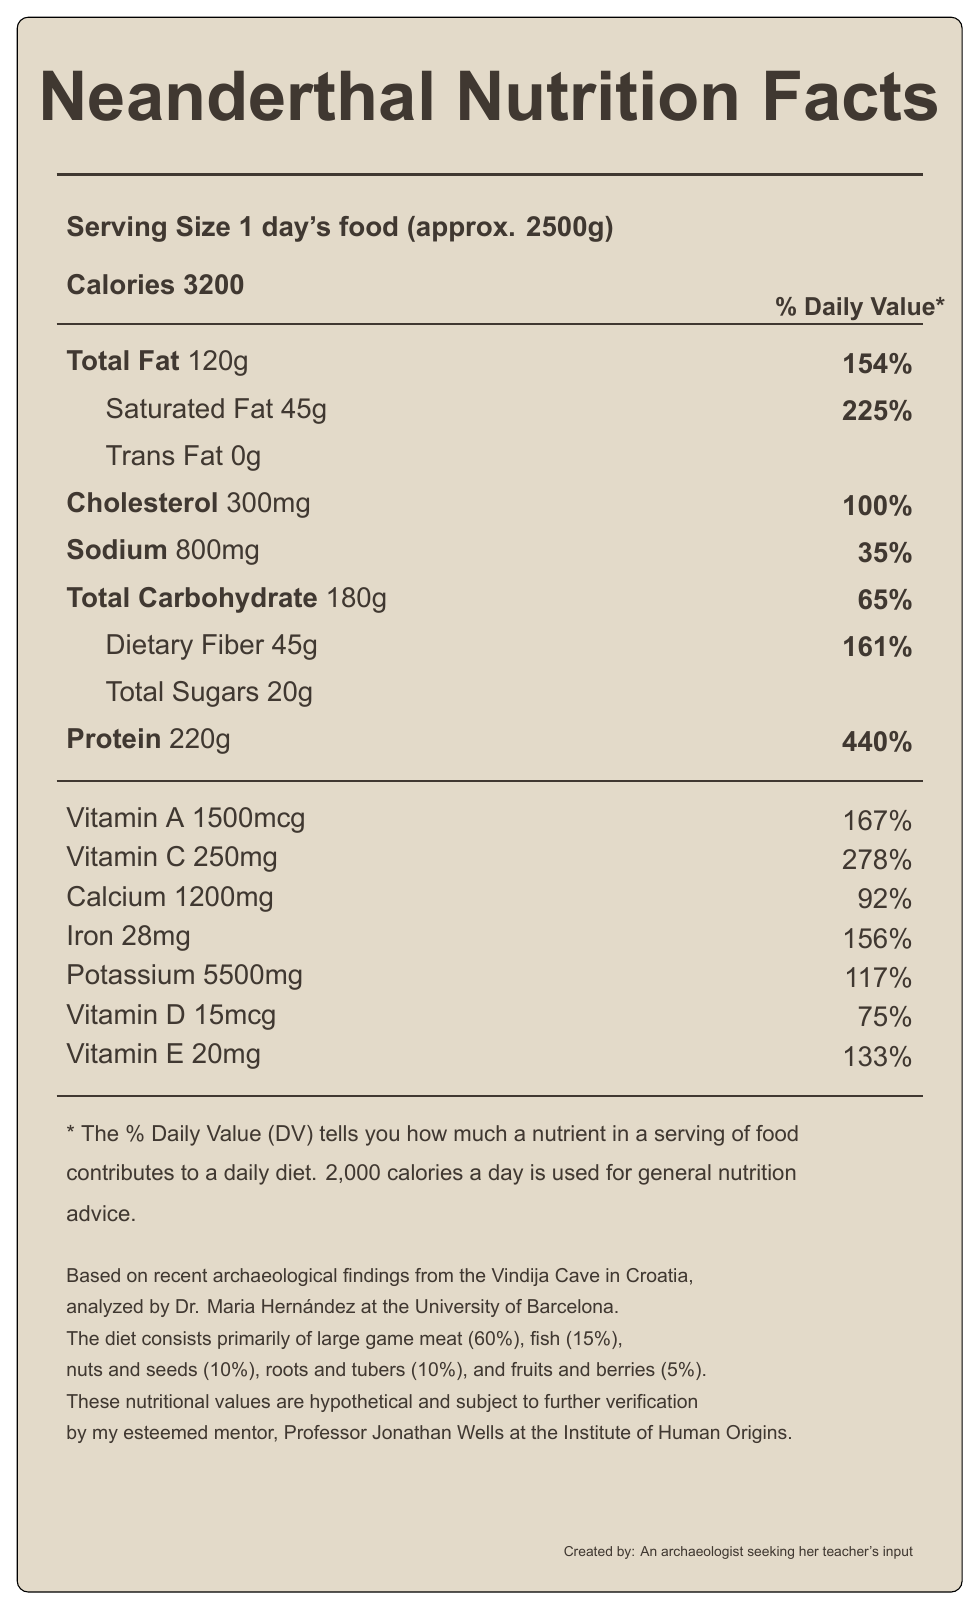what is the serving size described in the document? The serving size is clearly specified in the document as "1 day's food (approx. 2500g)".
Answer: 1 day's food (approx. 2500g) How many calories are in one serving? The document states that there are 3200 calories in one serving.
Answer: 3200 What percentage of the daily value of saturated fat is in the Neanderthal diet serving? According to the document, the daily value for saturated fat is 225%.
Answer: 225% Is there any trans fat in the Neanderthal diet serving? The document shows that the amount of trans fat is 0g, indicating there is no trans fat.
Answer: No Which nutrient has the highest percentage of daily value in the Neanderthal diet serving? With a daily value of 440%, protein has the highest percentage of daily value in the Neanderthal diet serving.
Answer: Protein Which of the following nutrients have amounts listed in milligrams (mg)? A) Vitamin A B) Iodine C) Manganese D) Vitamin D The document shows that Iodine is listed in micrograms (mcg), Vitamin A is listed in micrograms (mcg), Manganese in milligrams (mg), and Vitamin D in micrograms (mcg).
Answer: B) Iodine What percentage of the Neanderthal diet is made up of fruits and berries? The breakdown at the end of the document specifies that fruits and berries consist of 5% of the Neanderthal diet.
Answer: 5% True or false: The Neanderthal diet includes a significant amount of fish. The document states that 15% of the Neanderthal diet is composed of fish, which can be considered significant.
Answer: True Summarize the main nutritional insights from the Neanderthal diet label described in the document. The document gives a comprehensive overview of the nutritional values in a day's worth of Neanderthal diet, emphasizing a high-energy intake with significant contributions from various macronutrients and micronutrients.
Answer: The Neanderthal diet primarily consists of large game meat (60%), fish (15%), nuts and seeds (10%), roots and tubers (10%), and fruits and berries (5%). It provides 3200 calories per day's food with a high intake of protein (220g), fats (120g), and carbohydrates (180g), including 45g of dietary fiber. The diet has very high percentages of daily values for many vitamins and minerals, indicating nutrient richness. From the nutritional data on the label, what is the amount of chloride present in the Neanderthal diet serving? The document provides an amount of 3000mg for chloride present in the Neanderthal diet serving.
Answer: 3000mg What is the primary source of the nutrient data for the Neanderthal diet? A) University of Cambridge B) University of Barcelona C) University of Oxford The note at the end of the document mentions that the data is analyzed by Dr. Maria Hernández at the University of Barcelona.
Answer: B) University of Barcelona What would be an essential source of protein in the Neanderthal diet? The document specifies that large game meat constitutes 60% of the diet, which would be a major source of protein.
Answer: Large game meat What is the amount of vitamin B12 provided by one serving of the Neanderthal diet? The document lists the amount of vitamin B12 in the diet as 10mcg.
Answer: 10mcg Are the nutritional values verified by Professor Jonathan Wells? The document mentions that the values are subject to further verification by Professor Jonathan Wells at the Institute of Human Origins.
Answer: No How do the values of potassium and calcium compare in the Neanderthal diet? The document lists 5500mg of potassium and 1200mg of calcium, showing that potassium is significantly higher than calcium.
Answer: Potassium is much higher than calcium. What is the primary disclaimer associated with the nutritional values presented? The document clearly states that the presented values are hypothetical and require further verification by Professor Jonathan Wells.
Answer: These nutritional values are hypothetical and subject to further verification. Based on the label, what is the amount of dietary fiber in one serving of the Neanderthal diet? The document specifies that there are 45 grams of dietary fiber in one serving.
Answer: 45g Which of the following is not listed as part of the Neanderthal diet? A) Dairy B) Nuts and seeds C) Roots and tubers D) Fish The document does not mention dairy as part of the Neanderthal diet, while it does list nuts and seeds, roots and tubers, and fish.
Answer: A) Dairy What is the significance of the document mentioning Dr. Maria Hernández from the University of Barcelona? The document does not provide specific insights into the significance of Dr. Maria Hernández's involvement, nor details about her role beyond analyzing the findings.
Answer: Not enough information 